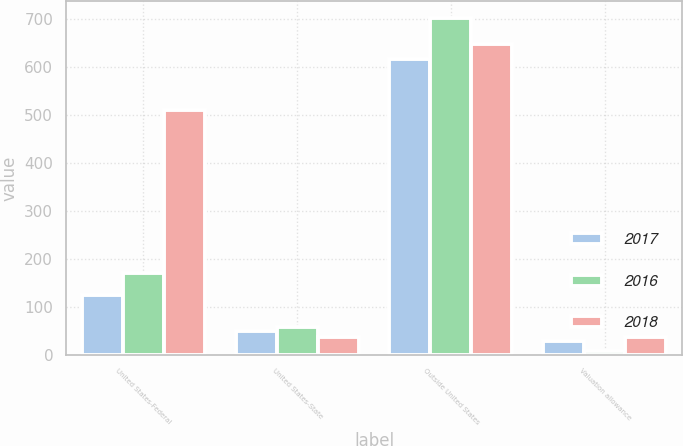<chart> <loc_0><loc_0><loc_500><loc_500><stacked_bar_chart><ecel><fcel>United States-Federal<fcel>United States-State<fcel>Outside United States<fcel>Valuation allowance<nl><fcel>2017<fcel>124<fcel>50<fcel>618<fcel>29<nl><fcel>2016<fcel>170<fcel>57<fcel>703<fcel>8<nl><fcel>2018<fcel>511<fcel>36<fcel>648<fcel>37<nl></chart> 